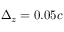<formula> <loc_0><loc_0><loc_500><loc_500>\Delta _ { z } = 0 . 0 5 c</formula> 